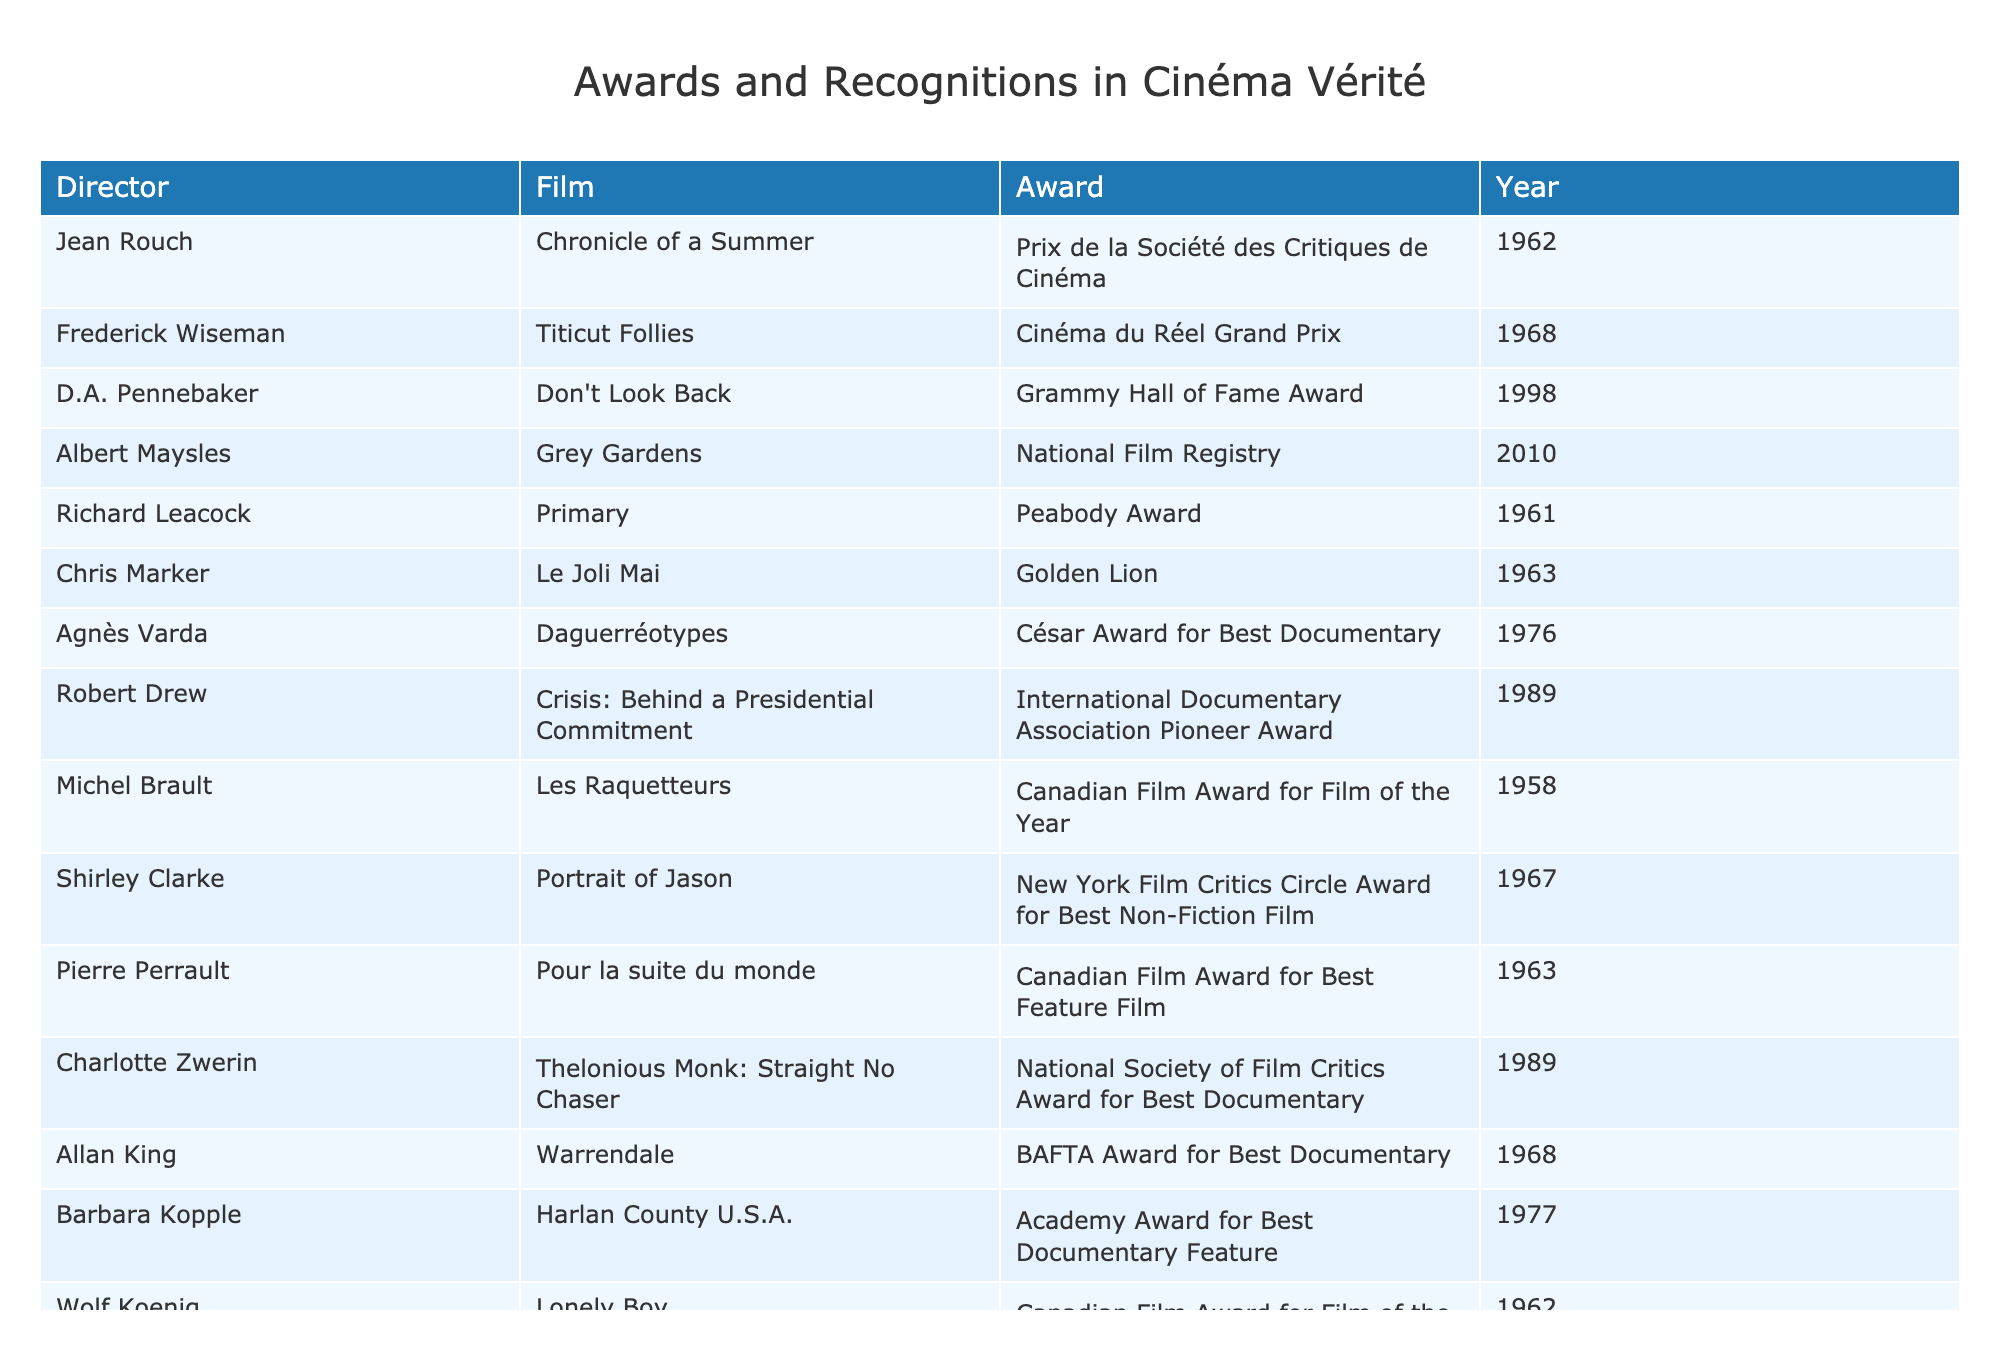What award did Jean Rouch receive for "Chronicle of a Summer"? The table indicates that Jean Rouch received the Prix de la Société des Critiques de Cinéma for his film "Chronicle of a Summer" in 1962.
Answer: Prix de la Société des Critiques de Cinéma How many awards did D.A. Pennebaker receive for his film "Don't Look Back"? According to the table, D.A. Pennebaker received one award, the Grammy Hall of Fame Award, for "Don't Look Back".
Answer: One Which year did Agnès Varda win the César Award for Best Documentary? The table shows that Agnès Varda won the César Award for Best Documentary in 1976 for her film "Daguerréotypes".
Answer: 1976 Who received the International Documentary Association Pioneer Award? The table states that Robert Drew received the International Documentary Association Pioneer Award for "Crisis: Behind a Presidential Commitment" in 1989.
Answer: Robert Drew Which director has the most recent award listed in the table? The most recent award in the table is the National Film Registry awarded to Albert Maysles for "Grey Gardens" in 2010. Thus, Albert Maysles has the most recent award.
Answer: Albert Maysles How many directors received awards in the 1960s? Counting the entries in the 1960s (Jean Rouch, Frederick Wiseman, Richard Leacock, Chris Marker, Shirley Clarke, Pierre Perrault, Allan King, Wolf Koenig), we find there are eight directors.
Answer: Eight Did any directors receive more than one award? Based on the table, all listed directors received only one award, so the answer is no.
Answer: No Which Canadian Film Award was given to Michel Brault and when? The table shows that Michel Brault received the Canadian Film Award for Film of the Year in 1958 for "Les Raquetteurs".
Answer: Film of the Year in 1958 How many films received an Academy Award for Best Documentary Feature? The table indicates that only one film, "Harlan County U.S.A." by Barbara Kopple, received the Academy Award for Best Documentary Feature.
Answer: One What is the difference in years between the earliest and latest awards in the table? The earliest award is in 1958 (Michel Brault), and the latest is in 2010 (Albert Maysles). The difference is 2010 - 1958 = 52 years.
Answer: 52 years Which director won an award in both Canada and the U.S.? The table shows that Barbara Kopple won an Academy Award in the U.S. and both Michel Brault and Wolf Koenig won Canadian Film Awards, but only Barbara Kopple holds an award from the U.S.
Answer: Barbara Kopple List the directors who won their awards in the 1970s? The table indicates that Agnès Varda (1976) and Barbara Kopple (1977) both won awards in the 1970s, resulting in two directors.
Answer: Two directors 